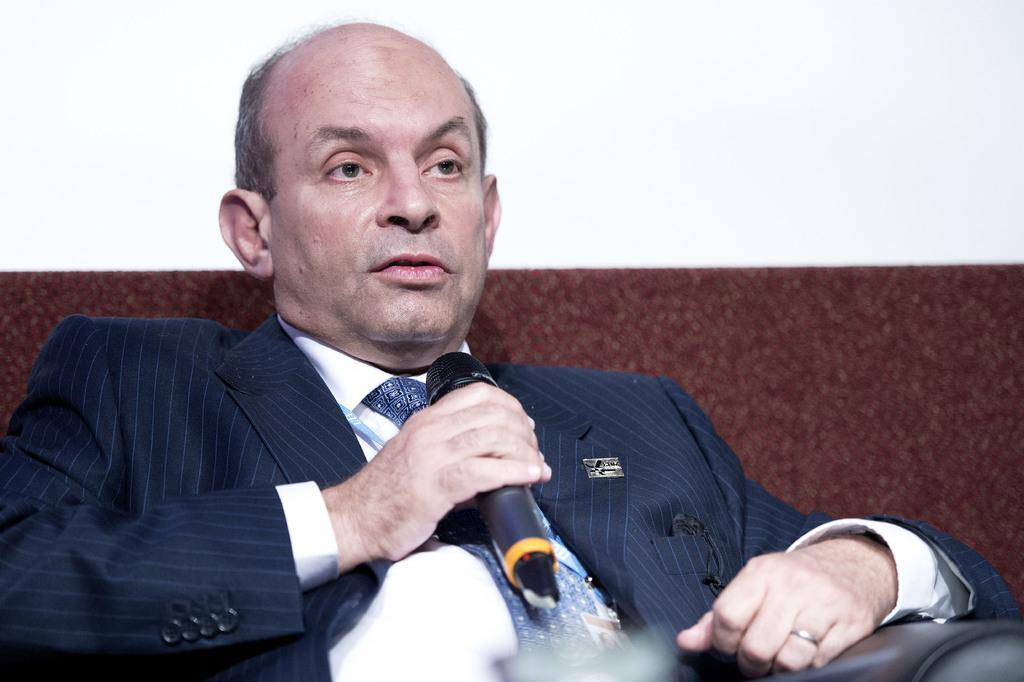What is the main subject of the image? The main subject of the image is a man. What is the man wearing on his upper body? The man is wearing a white shirt and a blue tie. What is the man wearing on his lower body? The man is wearing a blue suit. What is the man holding in his hand? The man is holding a mic in his hand. What type of wound can be seen on the man's eye in the image? There is no wound visible on the man's eye in the image. What color is the man's eye in the image? The provided facts do not mention the color of the man's eye, so it cannot be determined from the image. 